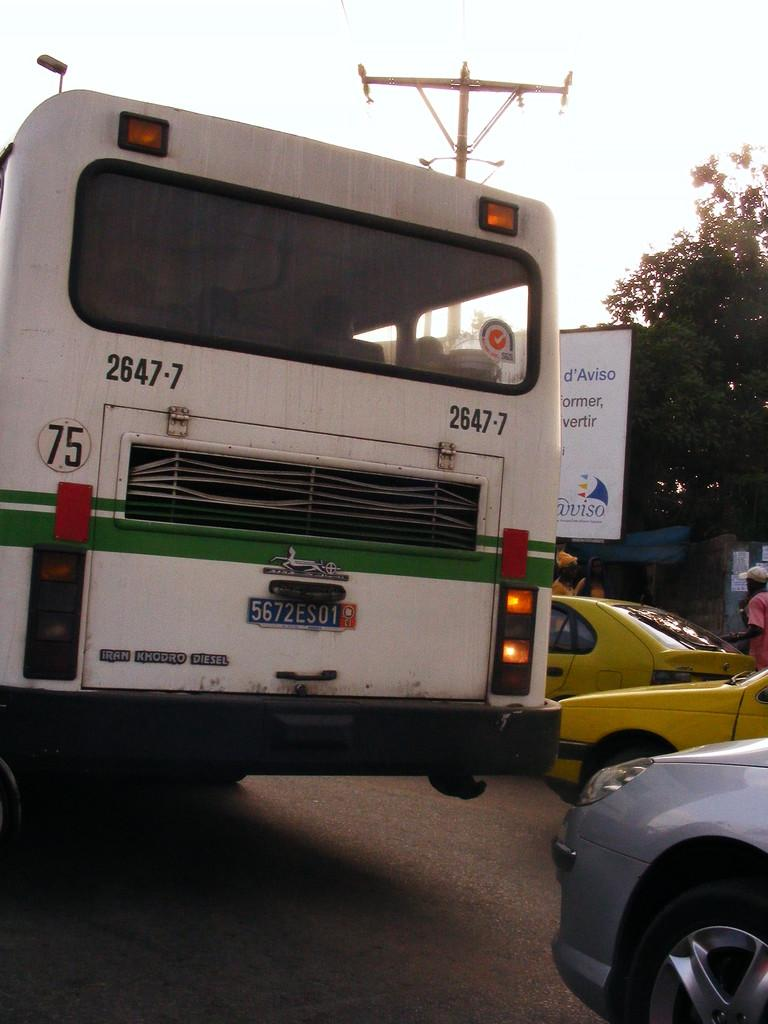<image>
Summarize the visual content of the image. The number 2647-7 is written twice on the back of this bus. 